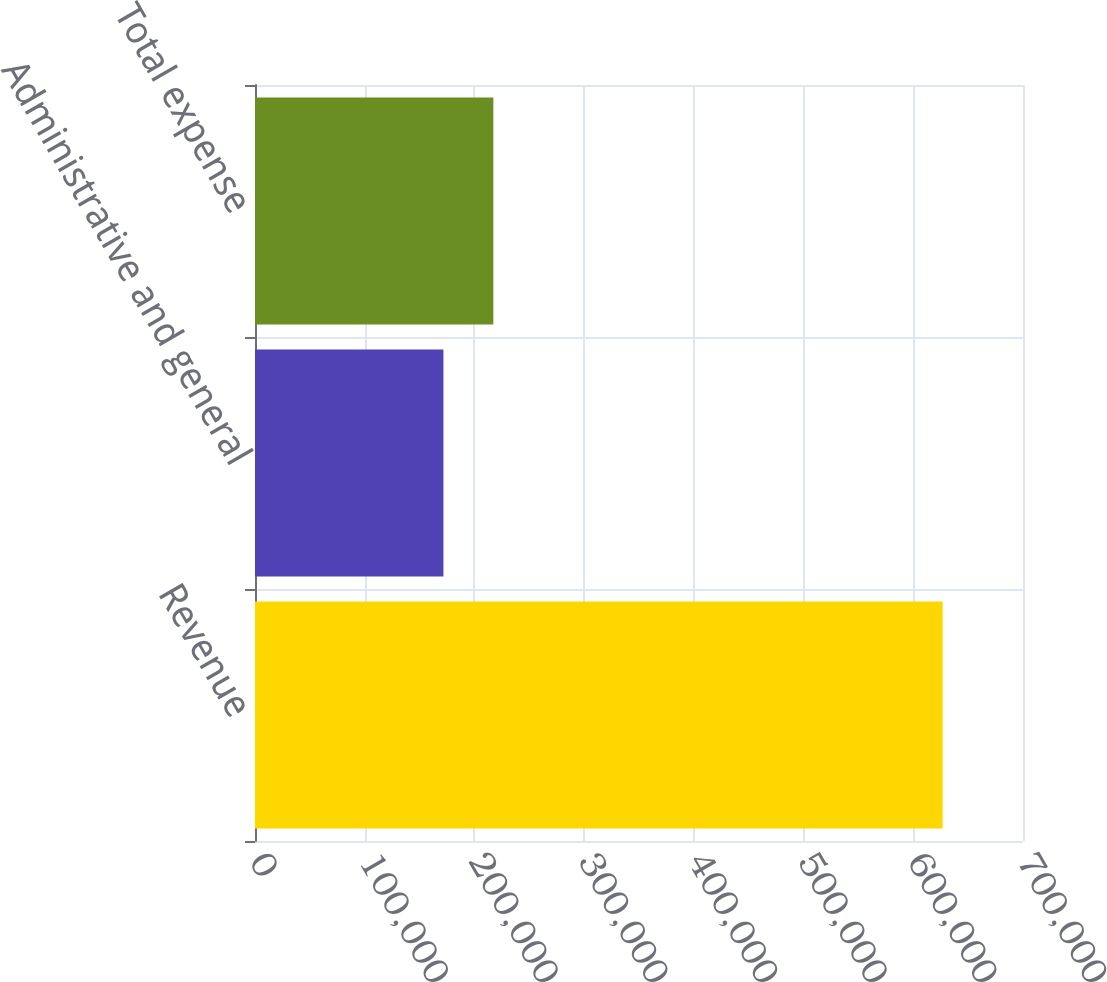<chart> <loc_0><loc_0><loc_500><loc_500><bar_chart><fcel>Revenue<fcel>Administrative and general<fcel>Total expense<nl><fcel>626764<fcel>171741<fcel>217243<nl></chart> 